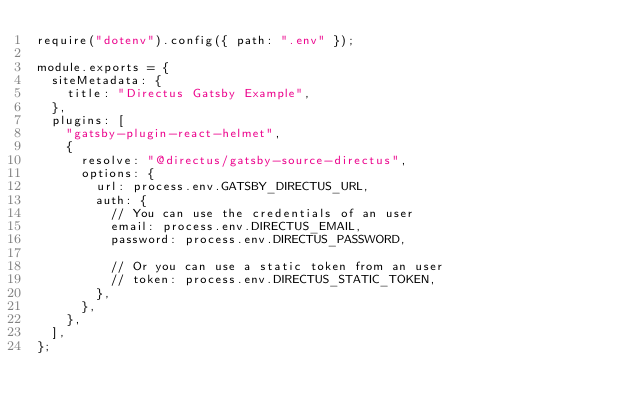Convert code to text. <code><loc_0><loc_0><loc_500><loc_500><_JavaScript_>require("dotenv").config({ path: ".env" });

module.exports = {
  siteMetadata: {
    title: "Directus Gatsby Example",
  },
  plugins: [
    "gatsby-plugin-react-helmet",
    {
      resolve: "@directus/gatsby-source-directus",
      options: {
        url: process.env.GATSBY_DIRECTUS_URL,
        auth: {
          // You can use the credentials of an user
          email: process.env.DIRECTUS_EMAIL,
          password: process.env.DIRECTUS_PASSWORD,

          // Or you can use a static token from an user
          // token: process.env.DIRECTUS_STATIC_TOKEN, 
        },
      },
    },
  ],
};
</code> 